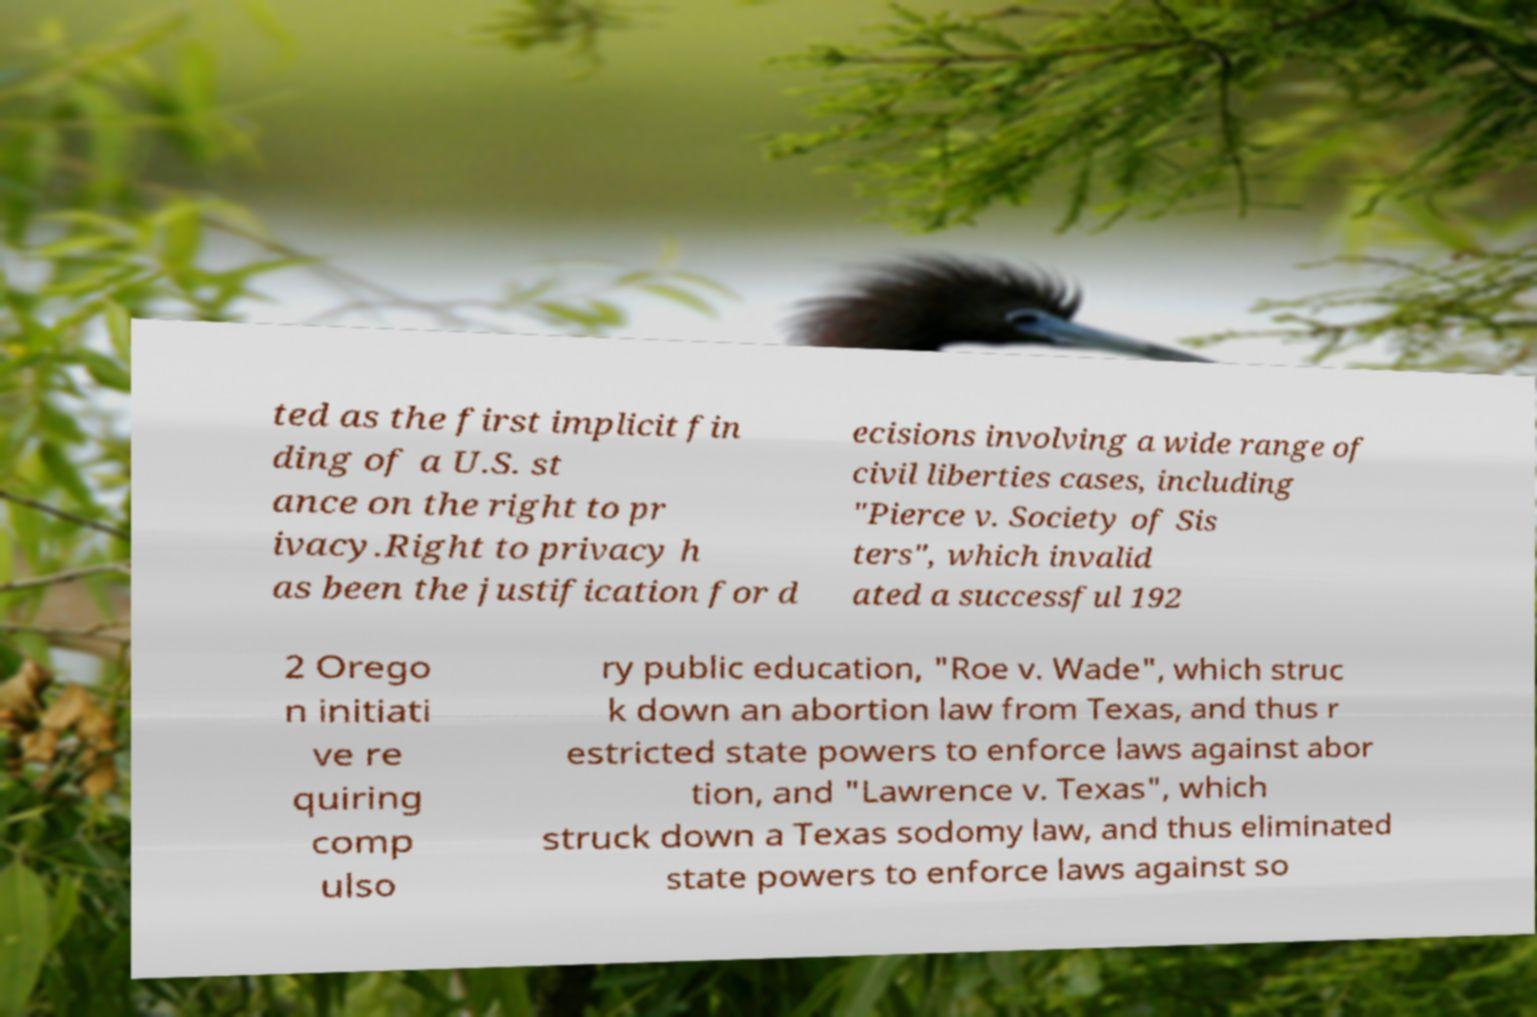Please read and relay the text visible in this image. What does it say? ted as the first implicit fin ding of a U.S. st ance on the right to pr ivacy.Right to privacy h as been the justification for d ecisions involving a wide range of civil liberties cases, including "Pierce v. Society of Sis ters", which invalid ated a successful 192 2 Orego n initiati ve re quiring comp ulso ry public education, "Roe v. Wade", which struc k down an abortion law from Texas, and thus r estricted state powers to enforce laws against abor tion, and "Lawrence v. Texas", which struck down a Texas sodomy law, and thus eliminated state powers to enforce laws against so 